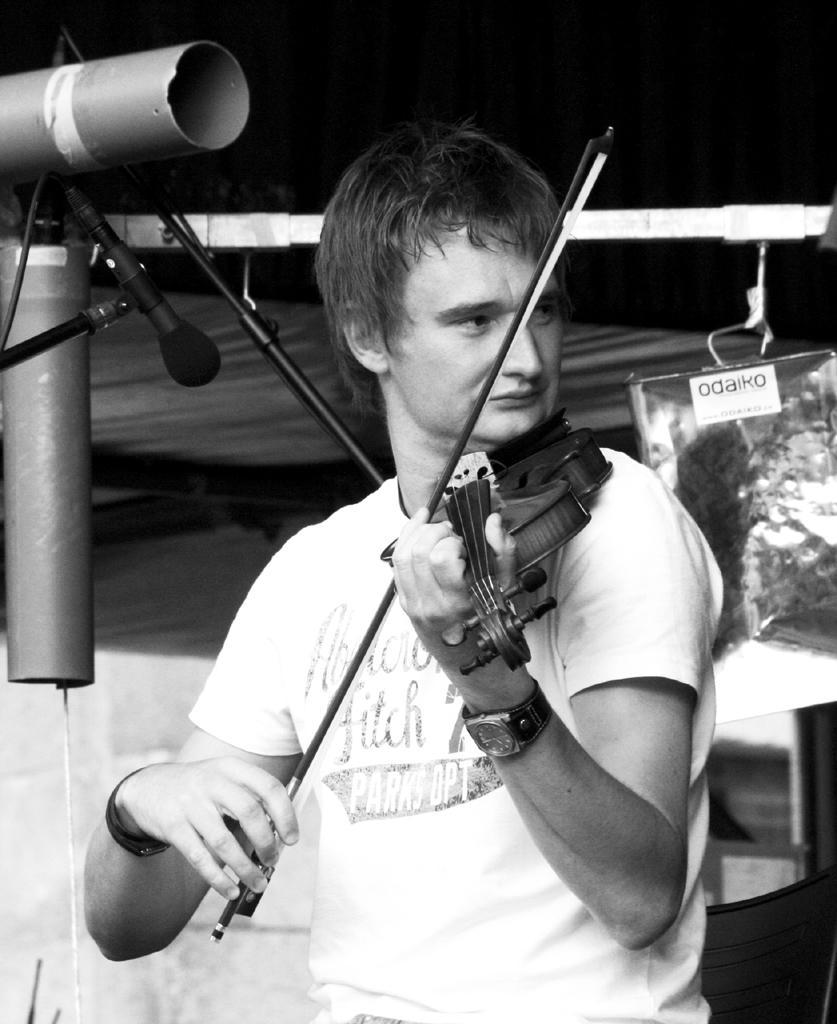Please provide a concise description of this image. In the image there is a man playing violin, on left side there is a mic to a stand, this is a black and white image. 